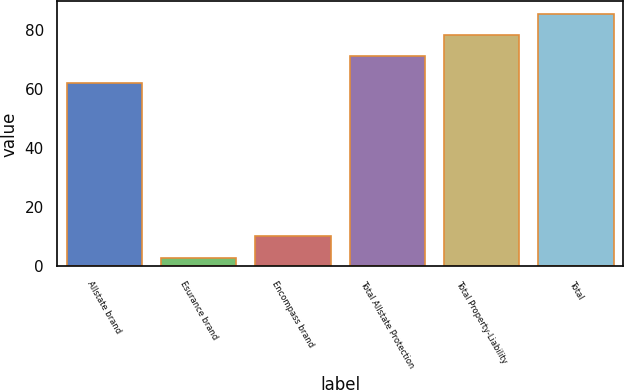Convert chart. <chart><loc_0><loc_0><loc_500><loc_500><bar_chart><fcel>Allstate brand<fcel>Esurance brand<fcel>Encompass brand<fcel>Total Allstate Protection<fcel>Total Property-Liability<fcel>Total<nl><fcel>62<fcel>3<fcel>10.2<fcel>71<fcel>78.2<fcel>85.4<nl></chart> 